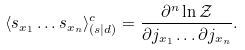Convert formula to latex. <formula><loc_0><loc_0><loc_500><loc_500>\langle s _ { x _ { 1 } } \dots s _ { x _ { n } } \rangle _ { ( s | d ) } ^ { c } = { \frac { \partial ^ { n } \ln { \mathcal { Z } } } { \partial j _ { x _ { 1 } } \dots \partial j _ { x _ { n } } } } .</formula> 